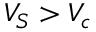Convert formula to latex. <formula><loc_0><loc_0><loc_500><loc_500>V _ { S } > V _ { c }</formula> 